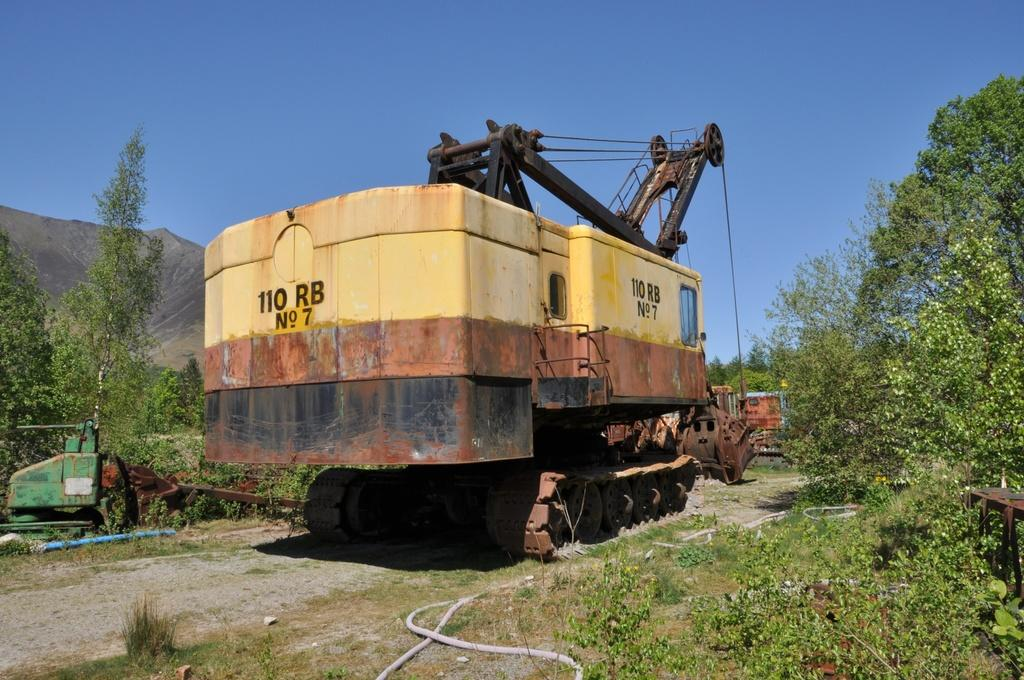What types of vehicles can be seen in the image? There are vehicles in the image, but the specific types cannot be determined from the provided facts. What other objects are present in the image besides vehicles? There are other objects in the image, but their nature cannot be determined from the provided facts. What type of vegetation is visible in the image? Grass, plants, and trees are visible in the image. What part of the natural environment is visible in the image? The sky is visible in the image. How much wealth is displayed by the vehicles in the image? There is no indication of wealth or the value of the vehicles in the image, as the provided facts do not mention any specific details about the vehicles. What type of hammer is being used to fix the vest in the image? There is no hammer or vest present in the image, so this question cannot be answered. 